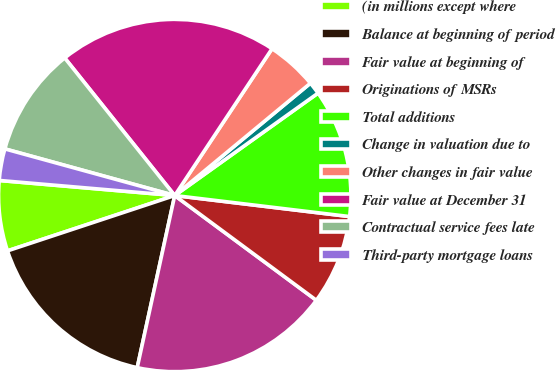Convert chart to OTSL. <chart><loc_0><loc_0><loc_500><loc_500><pie_chart><fcel>(in millions except where<fcel>Balance at beginning of period<fcel>Fair value at beginning of<fcel>Originations of MSRs<fcel>Total additions<fcel>Change in valuation due to<fcel>Other changes in fair value<fcel>Fair value at December 31<fcel>Contractual service fees late<fcel>Third-party mortgage loans<nl><fcel>6.45%<fcel>16.5%<fcel>18.28%<fcel>8.23%<fcel>11.78%<fcel>1.13%<fcel>4.68%<fcel>20.05%<fcel>10.0%<fcel>2.9%<nl></chart> 